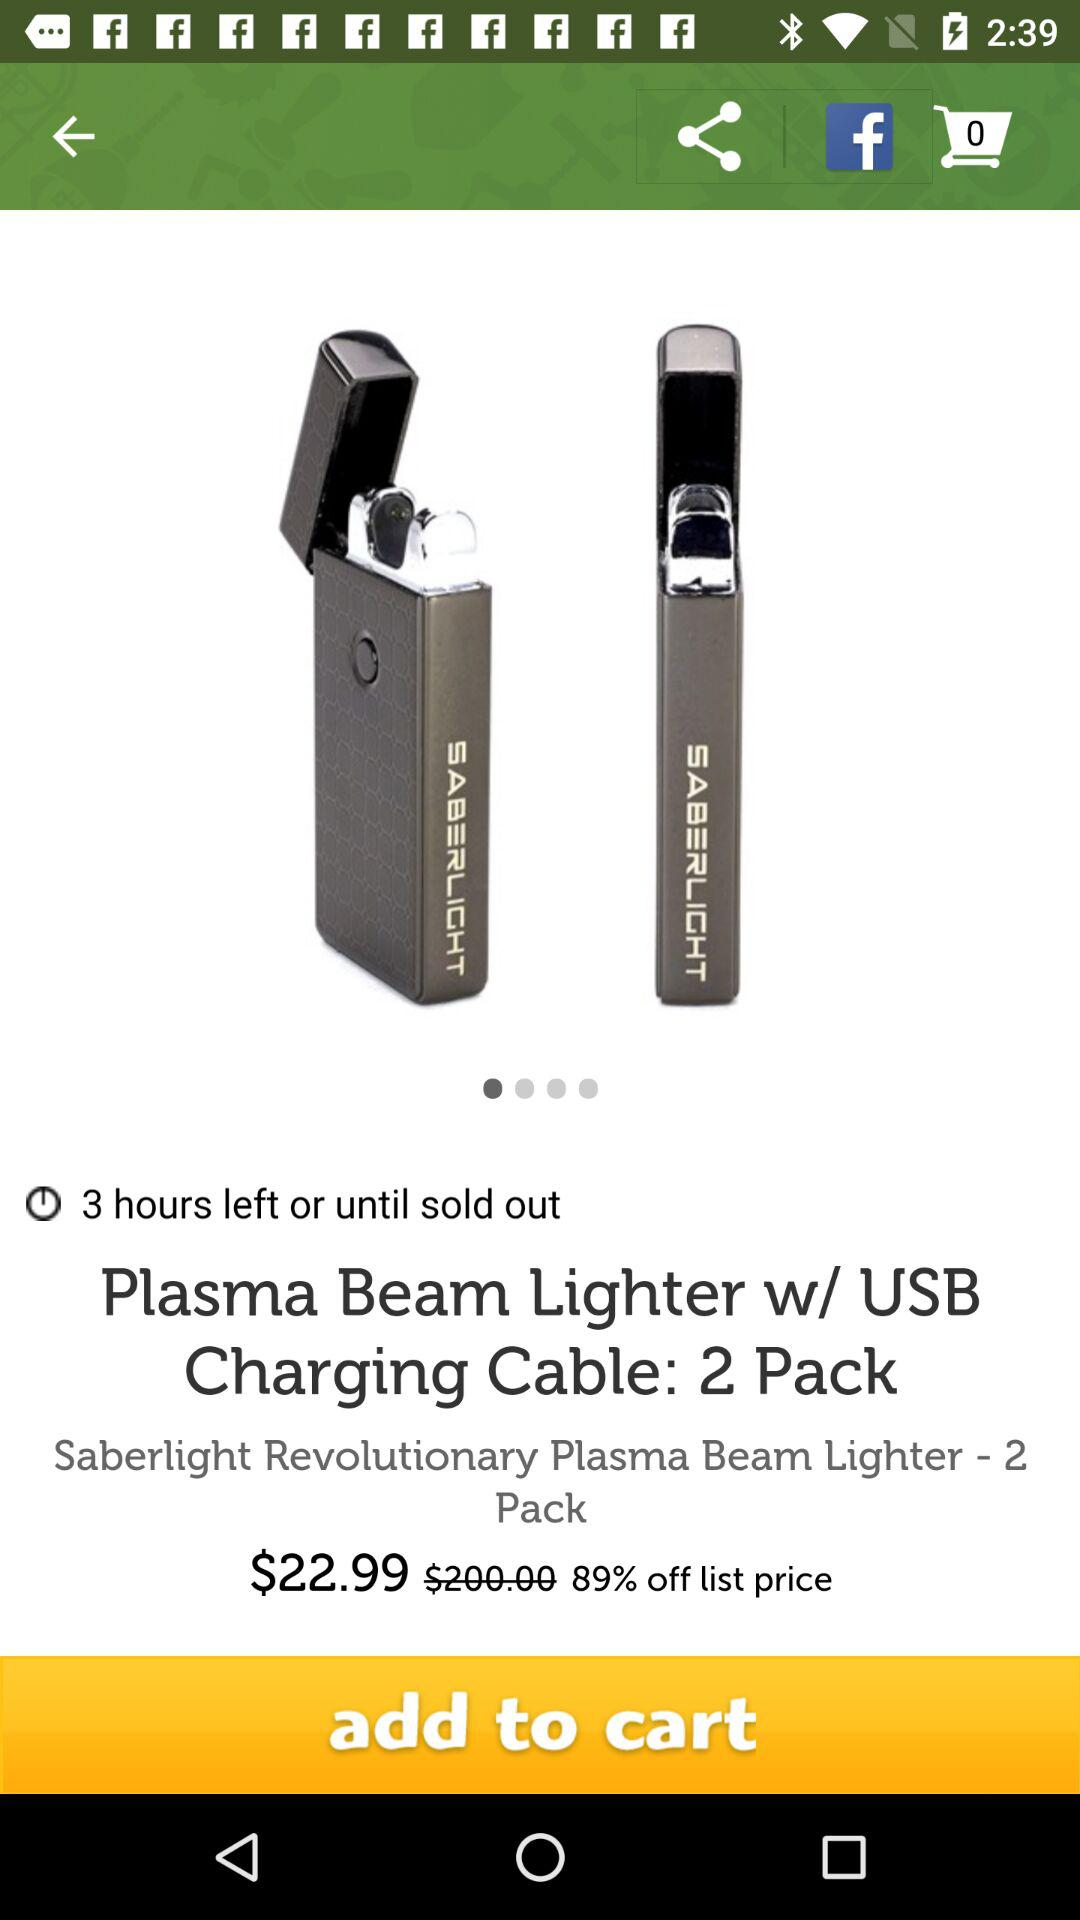How much is the discount? The discount is 89%. 